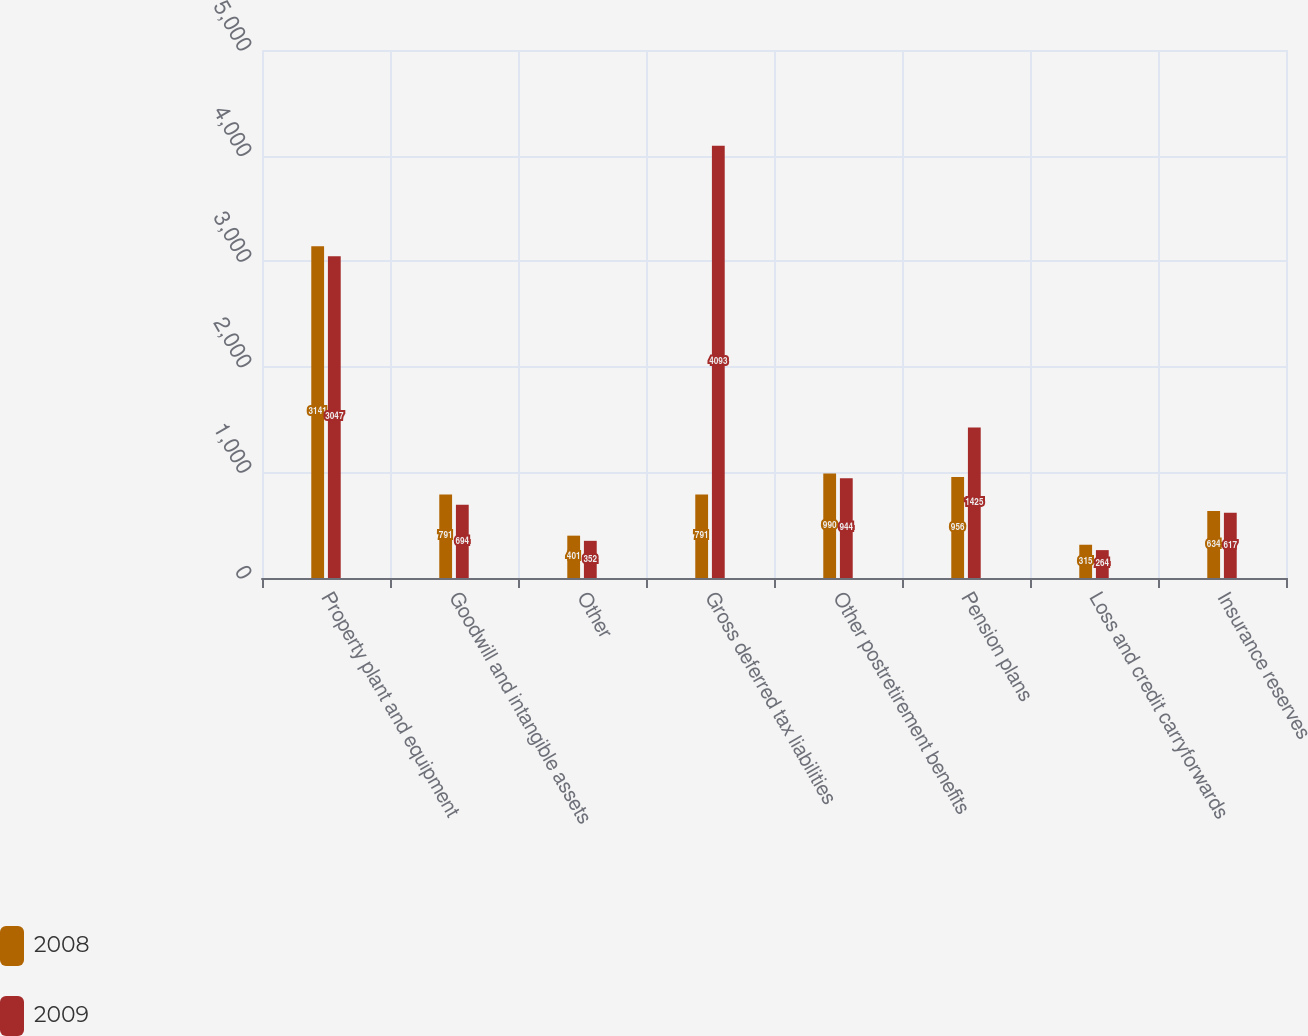<chart> <loc_0><loc_0><loc_500><loc_500><stacked_bar_chart><ecel><fcel>Property plant and equipment<fcel>Goodwill and intangible assets<fcel>Other<fcel>Gross deferred tax liabilities<fcel>Other postretirement benefits<fcel>Pension plans<fcel>Loss and credit carryforwards<fcel>Insurance reserves<nl><fcel>2008<fcel>3141<fcel>791<fcel>401<fcel>791<fcel>990<fcel>956<fcel>315<fcel>634<nl><fcel>2009<fcel>3047<fcel>694<fcel>352<fcel>4093<fcel>944<fcel>1425<fcel>264<fcel>617<nl></chart> 